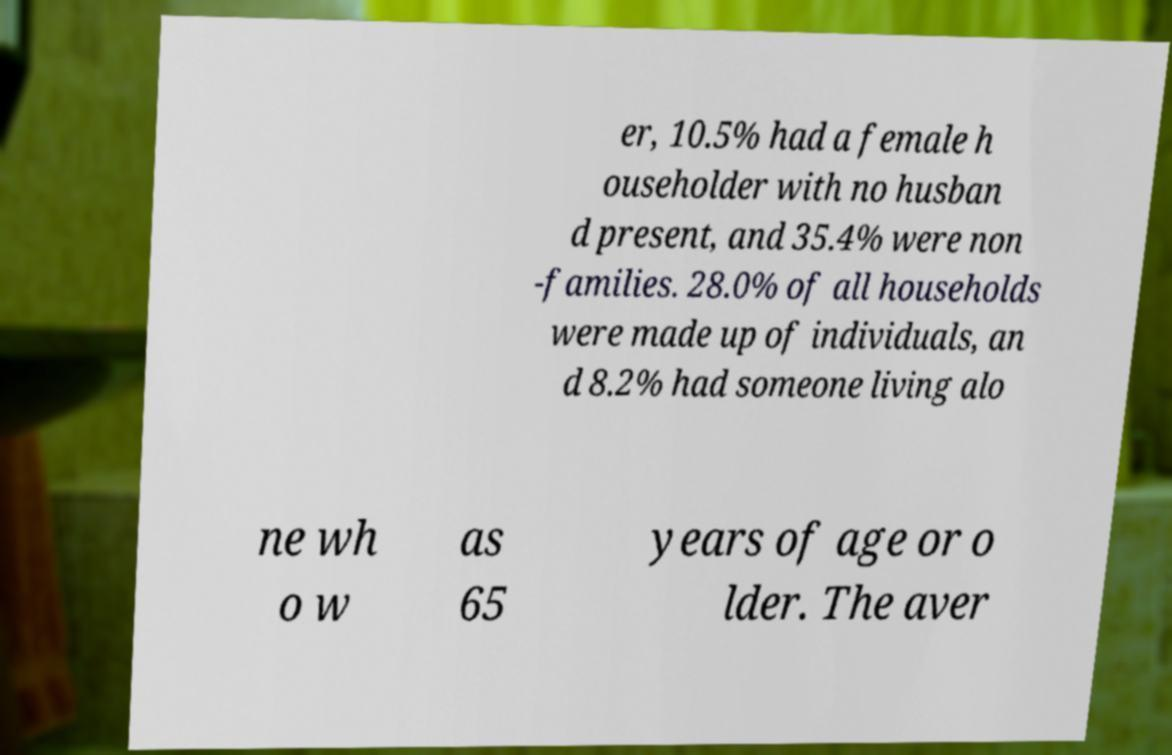For documentation purposes, I need the text within this image transcribed. Could you provide that? er, 10.5% had a female h ouseholder with no husban d present, and 35.4% were non -families. 28.0% of all households were made up of individuals, an d 8.2% had someone living alo ne wh o w as 65 years of age or o lder. The aver 